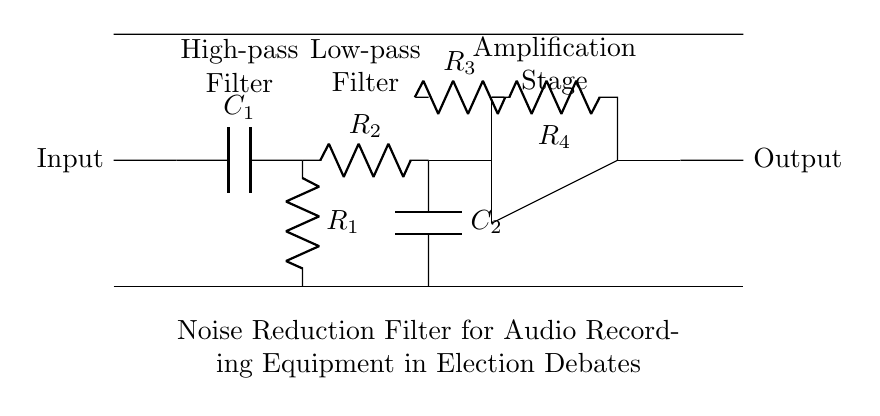What is the type of filter used in this circuit? The circuit incorporates both a high-pass filter and a low-pass filter, which allows for the selective frequency filtering essential for noise reduction.
Answer: Both What is the role of the operational amplifier in this filter circuit? The operational amplifier amplifies the filtered audio signal, enhancing its strength for output after passing through the filters.
Answer: Amplification How many resistors are present in the circuit? By inspecting the circuit diagram, there are four resistors labeled as R1, R2, R3, and R4.
Answer: Four What components comprise the high-pass filter? The high-pass filter consists of a capacitor and a resistor, specifically C1 and R1, which filter out lower frequencies.
Answer: C1, R1 Which component primarily removes low-frequency noise? The capacitor C2 in conjunction with the resistor R2 forms the low-pass filter, targeting and reducing low-frequency noise.
Answer: C2, R2 What is the purpose of feedback in this circuit? Feedback is implemented via resistor R4, controlling the gain and stability of the amplification stage, thus optimizing the signal quality.
Answer: Control gain 